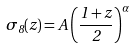Convert formula to latex. <formula><loc_0><loc_0><loc_500><loc_500>\sigma _ { 8 } ( z ) = A \left ( \frac { 1 + z } { 2 } \right ) ^ { \alpha }</formula> 